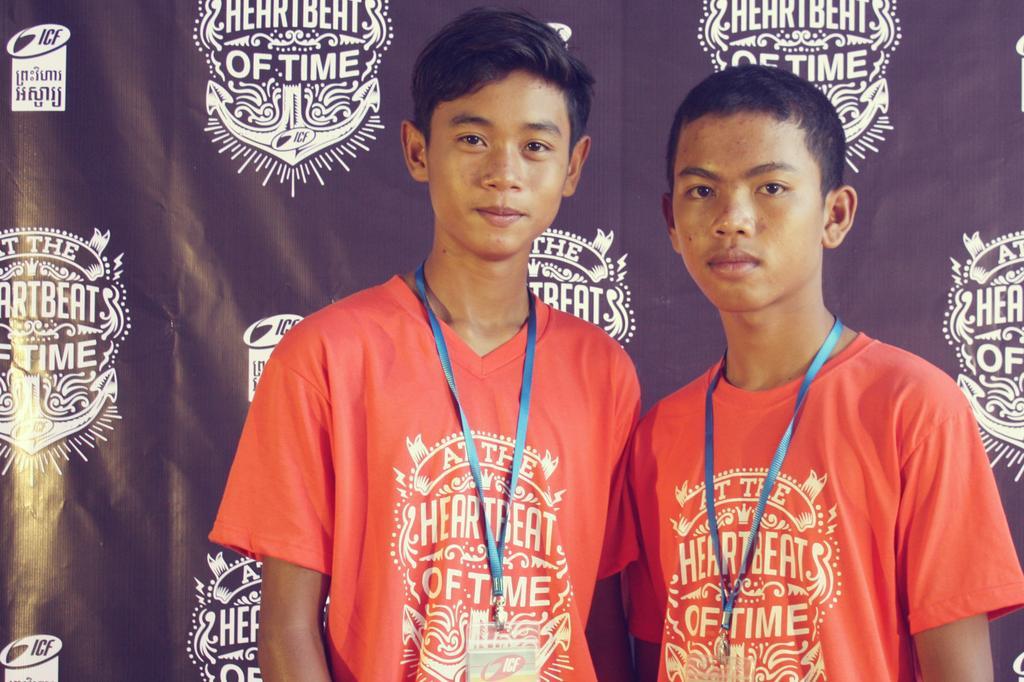In one or two sentences, can you explain what this image depicts? In this image we can see men standing and there is a curtain in the background. 